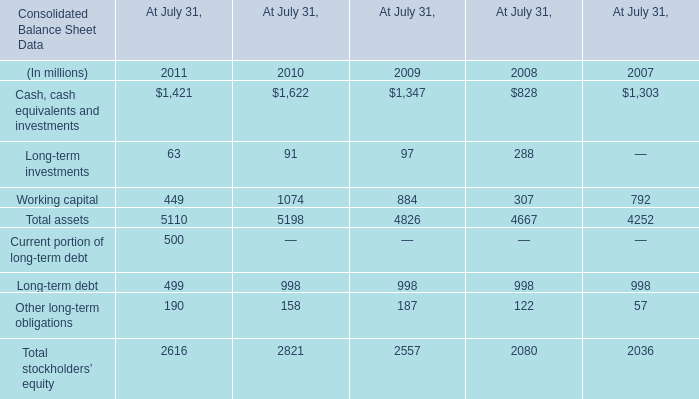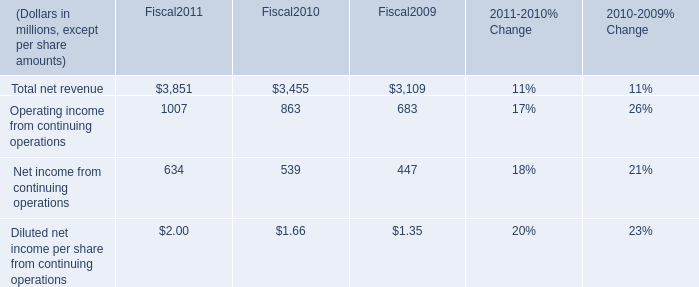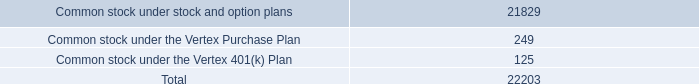What is the ratio of Working capital in Table 0 to the Total net revenue in Table 1 in 2010? 
Computations: (1074 / 3455)
Answer: 0.31085. 